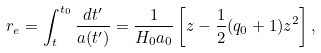Convert formula to latex. <formula><loc_0><loc_0><loc_500><loc_500>r _ { e } = \int _ { t } ^ { t _ { 0 } } \frac { d t ^ { \prime } } { a ( t ^ { \prime } ) } = \frac { 1 } { H _ { 0 } a _ { 0 } } \left [ z - \frac { 1 } { 2 } ( q _ { 0 } + 1 ) z ^ { 2 } \right ] ,</formula> 